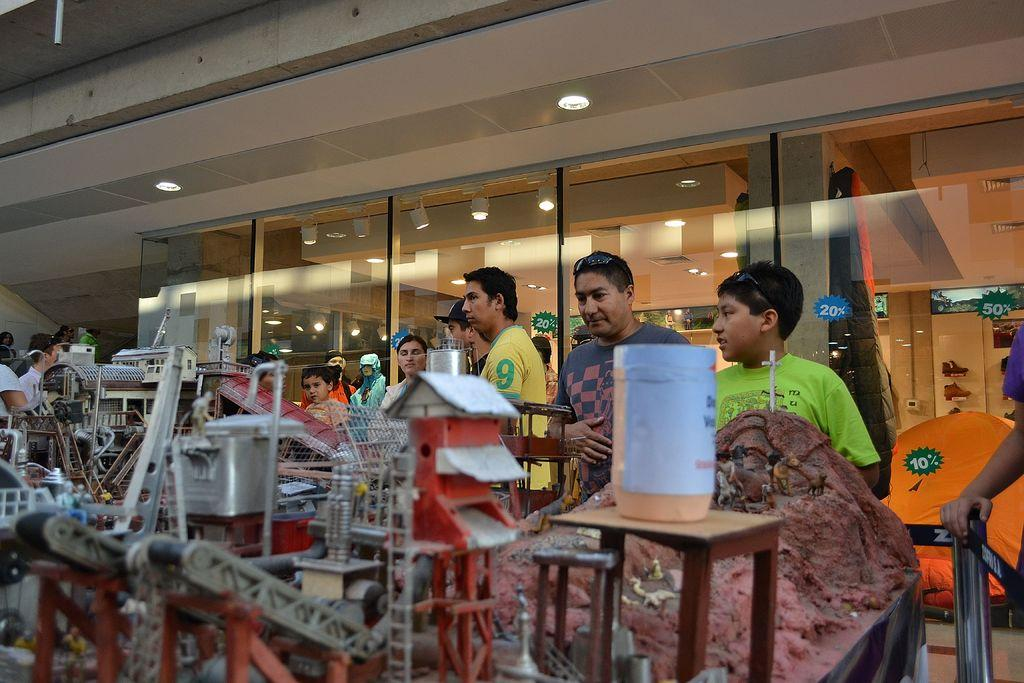What can be seen in the image? There are objects and people standing in the image. What type of architectural feature is visible in the image? Glass doors are visible in the image. What lighting is present in the image? Ceiling lights are present in the image. What type of nut is being used to write on the glass doors in the image? There is no nut present in the image, and the glass doors are not being used for writing. 